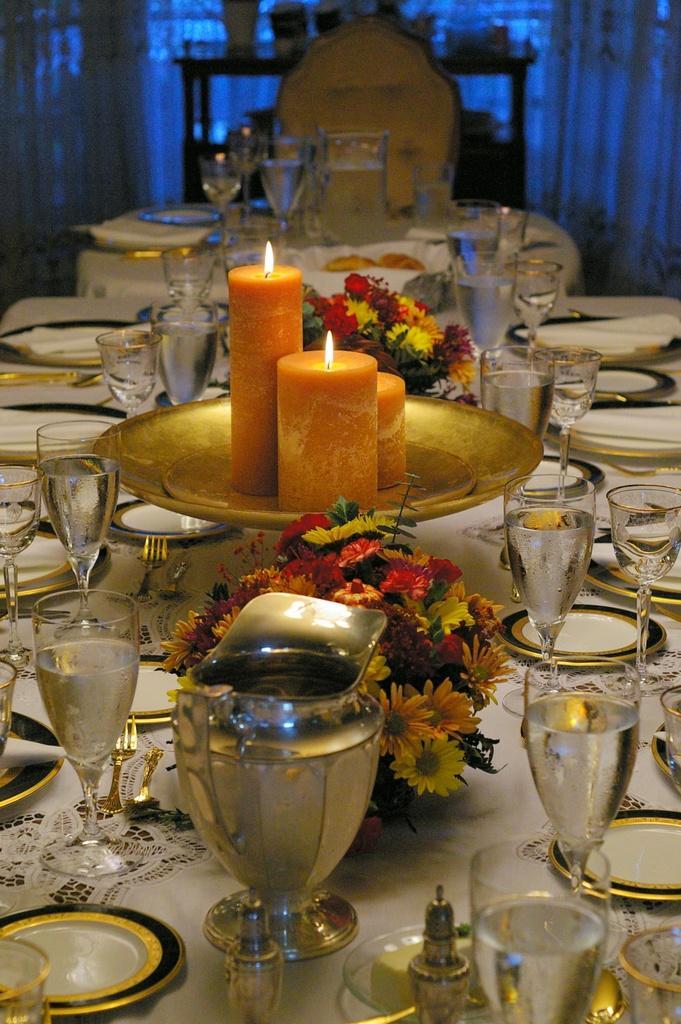How would you summarize this image in a sentence or two? In this image there is a dining table in middle of this image and there are some plates and some glasses are arranged on it. There is a candle as we can see in middle of this image and there are some flowers are at bottom side of this candle and top side of this candles. there is a chair on the top of this image and there are some curtains in the background. 